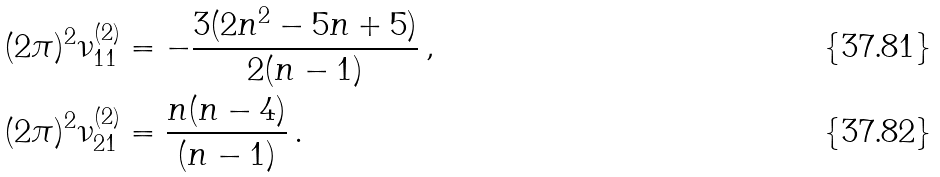Convert formula to latex. <formula><loc_0><loc_0><loc_500><loc_500>( 2 \pi ) ^ { 2 } \nu _ { 1 1 } ^ { ( 2 ) } & = - \frac { 3 ( 2 n ^ { 2 } - 5 n + 5 ) } { 2 ( n - 1 ) } \, , \\ ( 2 \pi ) ^ { 2 } \nu _ { 2 1 } ^ { ( 2 ) } & = \frac { n ( n - 4 ) } { ( n - 1 ) } \, .</formula> 